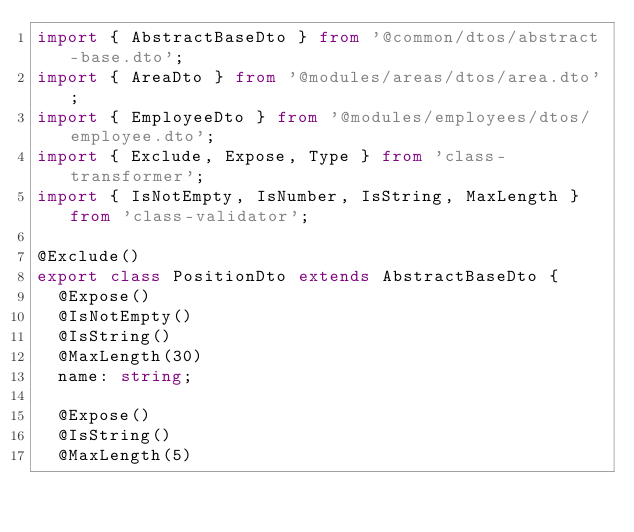<code> <loc_0><loc_0><loc_500><loc_500><_TypeScript_>import { AbstractBaseDto } from '@common/dtos/abstract-base.dto';
import { AreaDto } from '@modules/areas/dtos/area.dto';
import { EmployeeDto } from '@modules/employees/dtos/employee.dto';
import { Exclude, Expose, Type } from 'class-transformer';
import { IsNotEmpty, IsNumber, IsString, MaxLength } from 'class-validator';

@Exclude()
export class PositionDto extends AbstractBaseDto {
  @Expose()
  @IsNotEmpty()
  @IsString()
  @MaxLength(30)
  name: string;

  @Expose()
  @IsString()
  @MaxLength(5)</code> 